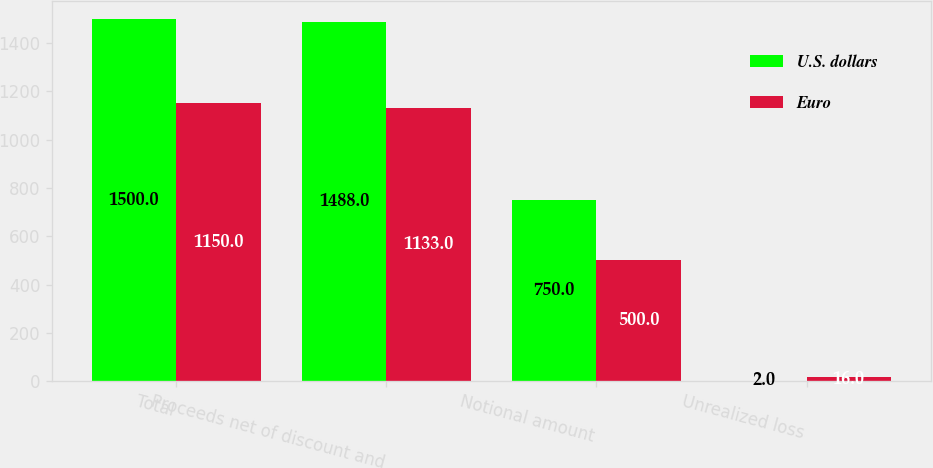Convert chart. <chart><loc_0><loc_0><loc_500><loc_500><stacked_bar_chart><ecel><fcel>Total<fcel>Proceeds net of discount and<fcel>Notional amount<fcel>Unrealized loss<nl><fcel>U.S. dollars<fcel>1500<fcel>1488<fcel>750<fcel>2<nl><fcel>Euro<fcel>1150<fcel>1133<fcel>500<fcel>16<nl></chart> 